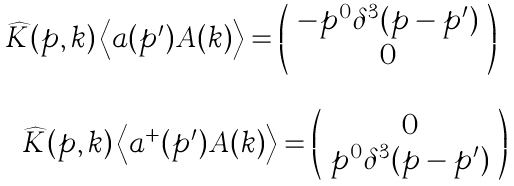<formula> <loc_0><loc_0><loc_500><loc_500>\begin{array} { c } \widehat { K } ( p , k ) \left \langle a ( p ^ { \prime } ) { A ( } k ) \right \rangle = \left ( \begin{array} { c } - p ^ { 0 } \delta ^ { 3 } ( { p - p ^ { \prime } ) } \\ 0 \end{array} \right ) \\ \\ \quad \widehat { K } ( p , k ) \left \langle a ^ { + } ( p ^ { \prime } ) { A ( } k ) \right \rangle = \left ( \begin{array} { c } 0 \\ p ^ { 0 } \delta ^ { 3 } ( { p - p ^ { \prime } ) } \end{array} \right ) \end{array}</formula> 